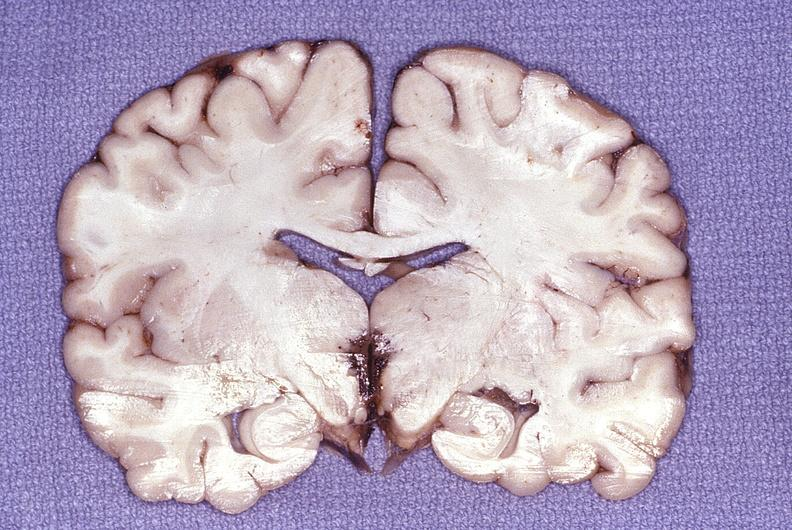what does this image show?
Answer the question using a single word or phrase. Wernicke 's encephalopathy 